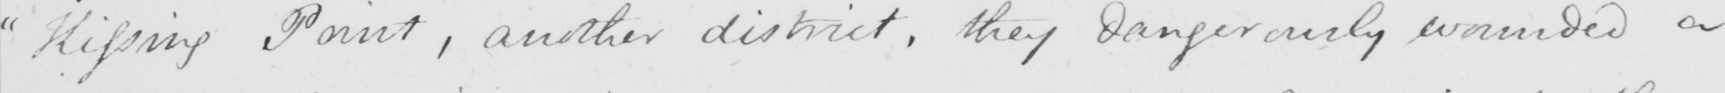Can you read and transcribe this handwriting? Kissing Point , another district , they dangerously wounded a 